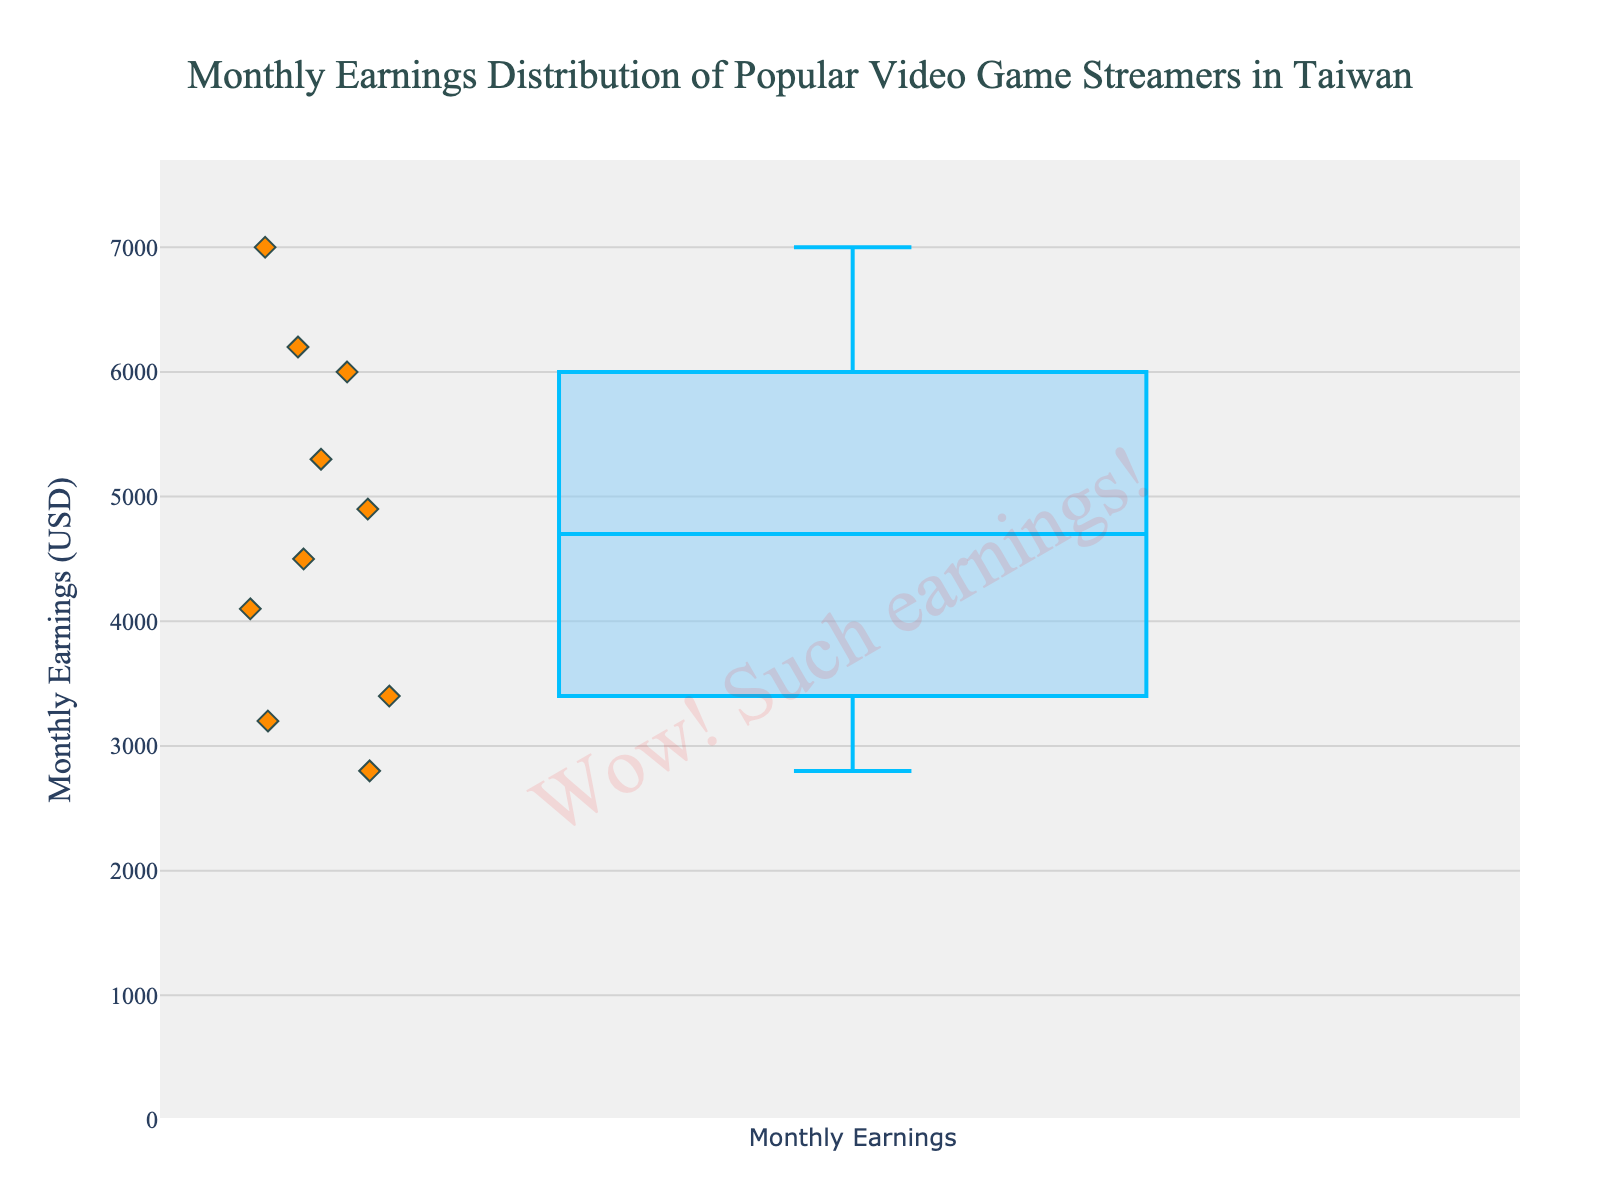What's the title of the figure? The title is a clear component positioned at the top center of the figure. It usually provides an overview of what the figure represents. The title in this figure is "Monthly Earnings Distribution of Popular Video Game Streamers in Taiwan".
Answer: Monthly Earnings Distribution of Popular Video Game Streamers in Taiwan What does the y-axis represent? The y-axis title is usually labeled alongside the axis and represents the measurement unit. In this case, it is labeled as "Monthly Earnings (USD)".
Answer: Monthly Earnings (USD) How many streamers' earnings are shown in the plot? The box plot shows all individual data points along with the box. By counting the points, we can determine the number of streamers. There are 10 data points visible.
Answer: 10 Which streamer has the highest monthly earnings? Each data point is labeled with the streamer's name. The highest earnings data point is the highest point on the y-axis. TsunamiToby is shown at the highest point.
Answer: TsunamiToby What's the median monthly earnings of the streamers? In a box plot, the median is represented by the line within the box. This line is at $4,900.
Answer: $4,900 What is the interquartile range (IQR) of the monthly earnings? The IQR is the range between the first quartile (Q1) and the third quartile (Q3). In the box plot, this is the length of the box itself. The Q1 is about $3,400, and the Q3 is about $6,000. The IQR is $6,000 - $3,400 = $2,600.
Answer: $2,600 Which streamer earns less than the median but more than the first quartile? This question requires to filter out the streamers whose earnings fall in the range between Q1 and the median. The Q1 is $3,400 and the median is $4,900. The streamers in this range are PixelFreak with $4,100 and LunaLight with $3,400.
Answer: PixelFreak and LunaLight What streamer has earnings closest to the third quartile (Q3)? The third quartile (Q3) is the upper boundary of the box. The third quartile is around $6,000 and the streamer earning closest to this point is DiamondDiva, who also has $6,000 earnings.
Answer: DiamondDiva Which streamer has the earnings furthest from the median? The median is $4,900. The furthest earnings point is the one with the largest absolute difference from the median. TsunamiToby has earnings of $7,000 which has the largest difference from $4,900 ($7,000 - $4,900 = $2,100).
Answer: TsunamiToby 